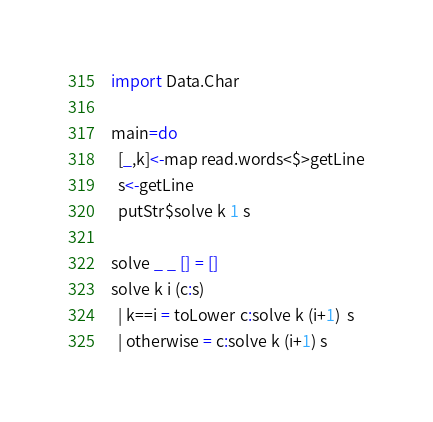Convert code to text. <code><loc_0><loc_0><loc_500><loc_500><_Haskell_>import Data.Char

main=do
  [_,k]<-map read.words<$>getLine
  s<-getLine
  putStr$solve k 1 s

solve _ _ [] = []
solve k i (c:s)
  | k==i = toLower c:solve k (i+1)  s
  | otherwise = c:solve k (i+1) s</code> 